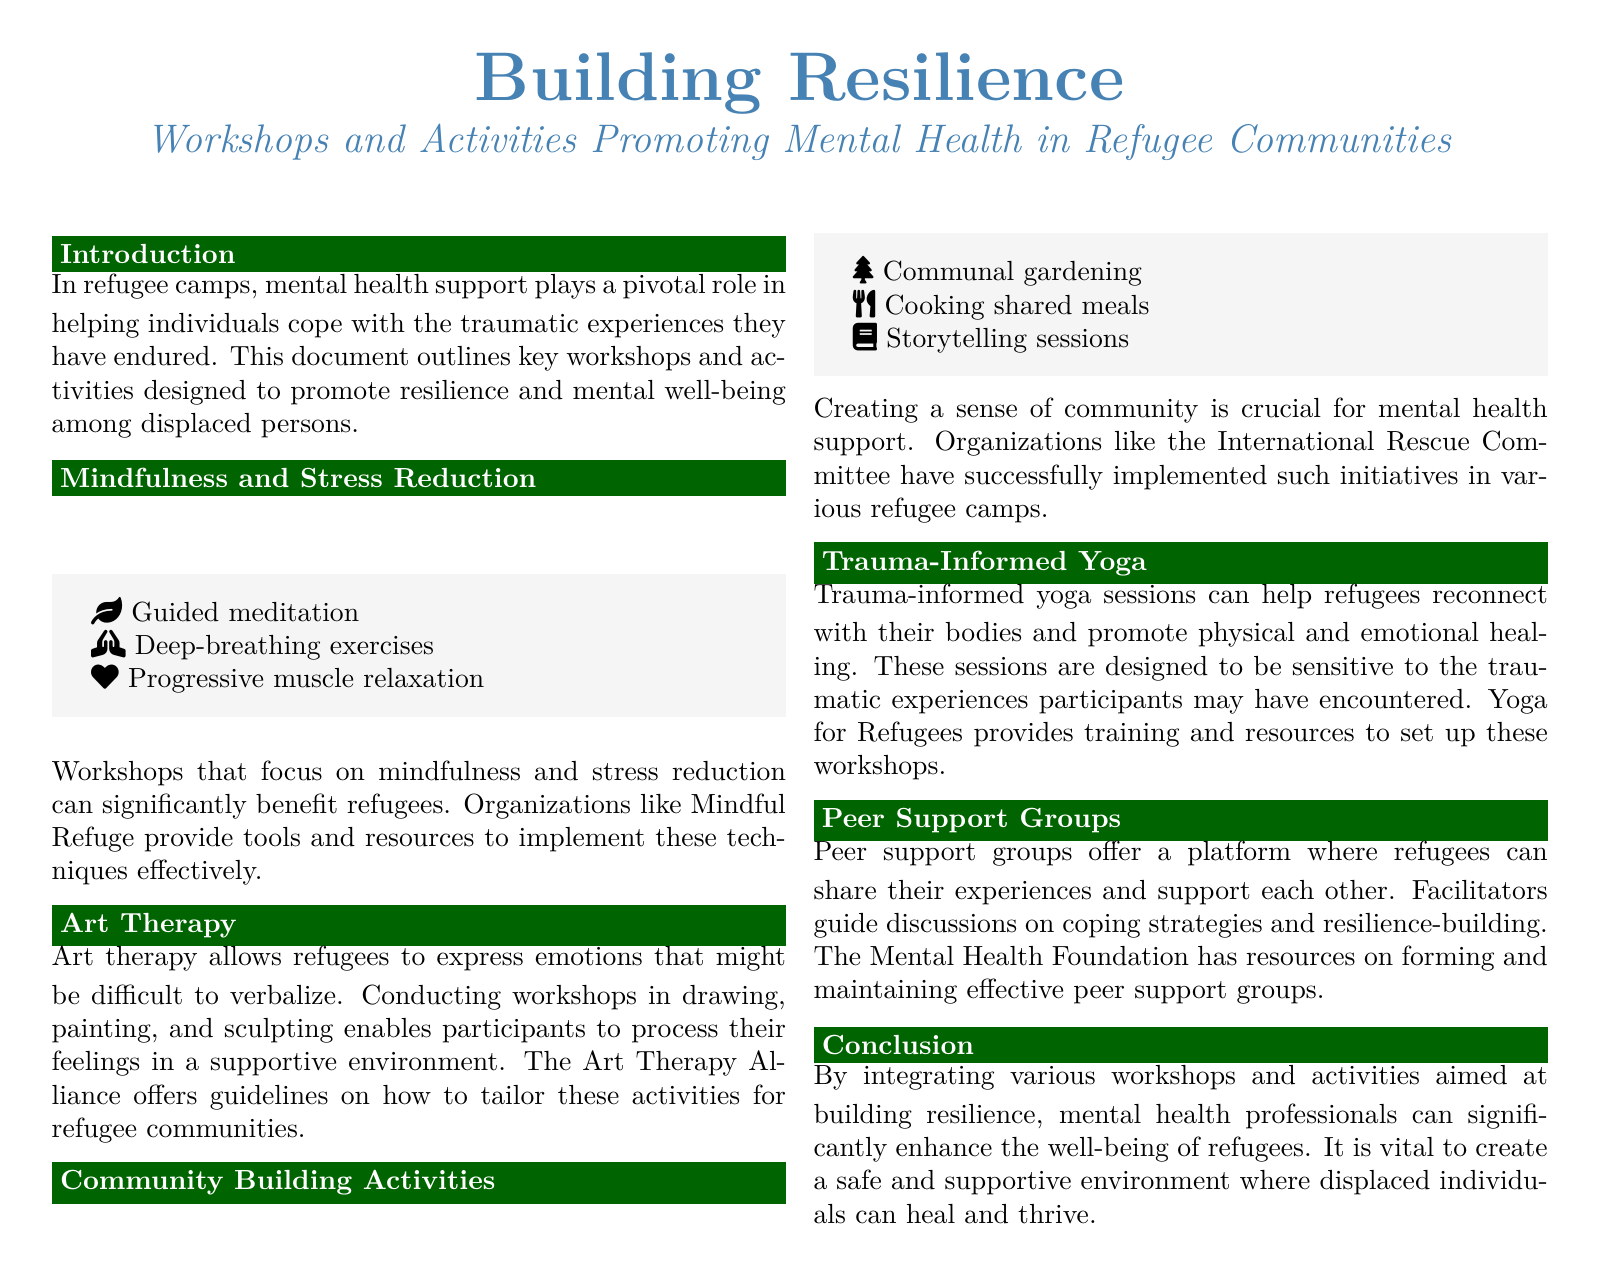what is the title of the document? The title of the document outlines the main theme of mental health support in refugee communities.
Answer: Building Resilience who provides resources for trauma-informed yoga? This information is found in the section discussing the specific activities and the organizations involved.
Answer: Yoga for Refugees name one activity that promotes community building. The document lists several activities aimed at fostering community among refugees.
Answer: Cooking shared meals what does art therapy help refugees to express? The document specifies the purpose of art therapy activities in helping refugees.
Answer: Emotions which organization offers guidelines for art therapy? The document mentions specific organizations related to the workshops described.
Answer: The Art Therapy Alliance how many workshop types are mentioned in the document? This is an information retrieval question that requires counting the distinct workshop types listed.
Answer: Five what mental health support element is emphasized in peer support groups? The document outlines a key focus of peer support groups within the community.
Answer: Coping strategies what color is used for the header box? This is a document-specific question that pertains to the design elements within the layout.
Answer: Header color which organization implements communal gardening in refugee camps? The document references organizations that help with community building activities.
Answer: International Rescue Committee 